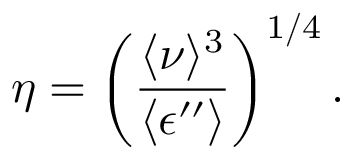<formula> <loc_0><loc_0><loc_500><loc_500>\eta = \left ( \frac { \langle \nu \rangle ^ { 3 } } { \langle \epsilon ^ { \prime \prime } \rangle } \right ) ^ { 1 / 4 } .</formula> 